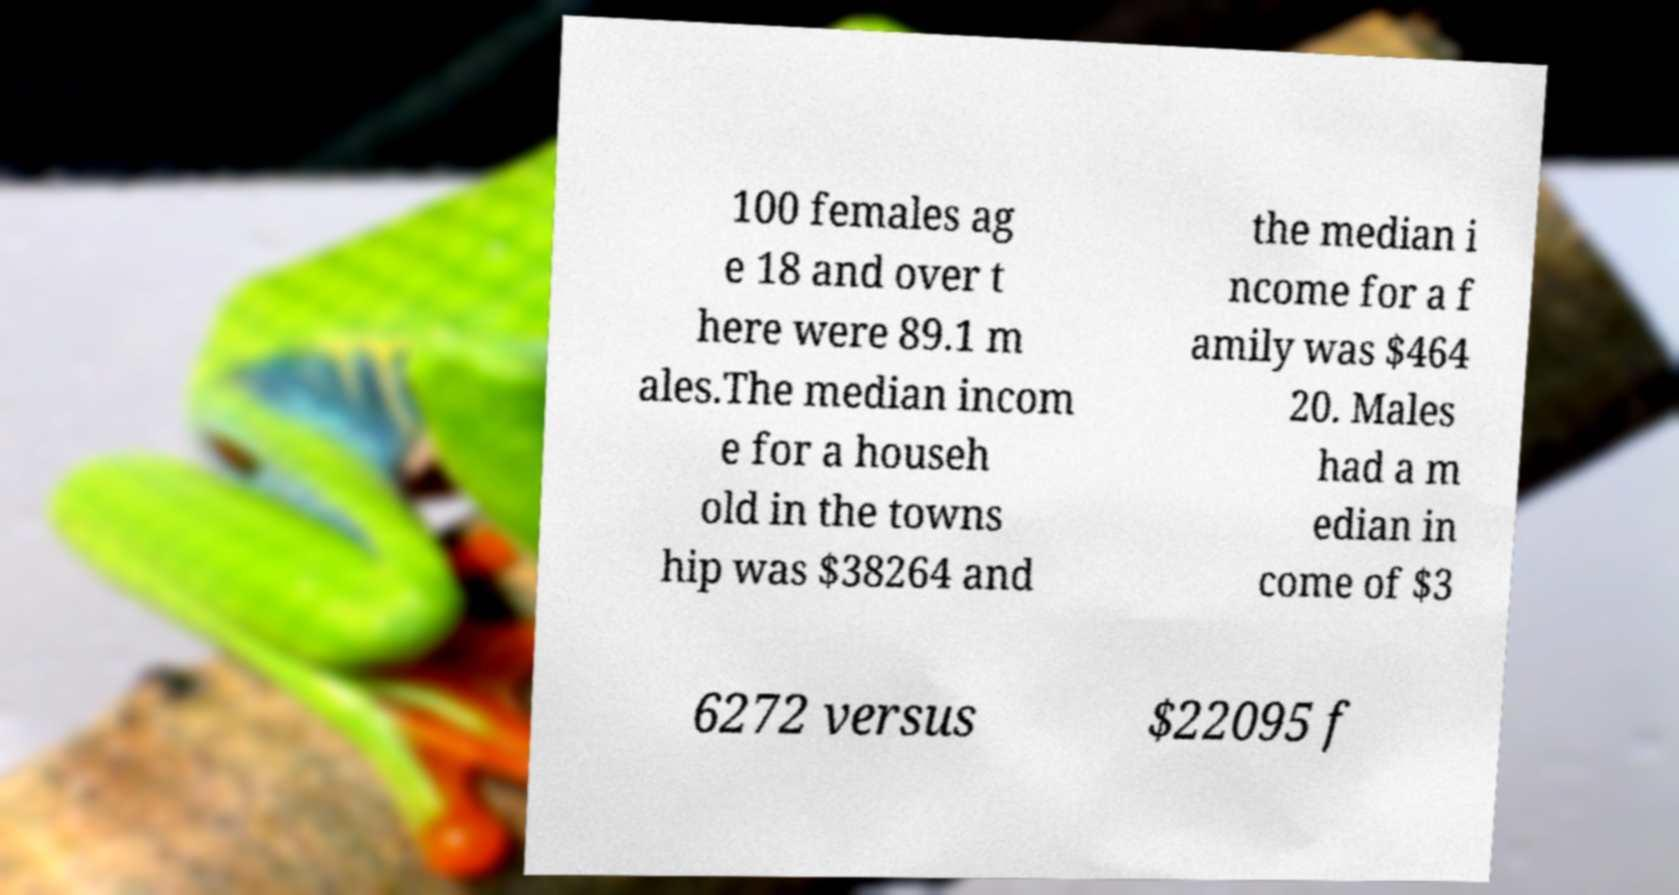There's text embedded in this image that I need extracted. Can you transcribe it verbatim? 100 females ag e 18 and over t here were 89.1 m ales.The median incom e for a househ old in the towns hip was $38264 and the median i ncome for a f amily was $464 20. Males had a m edian in come of $3 6272 versus $22095 f 